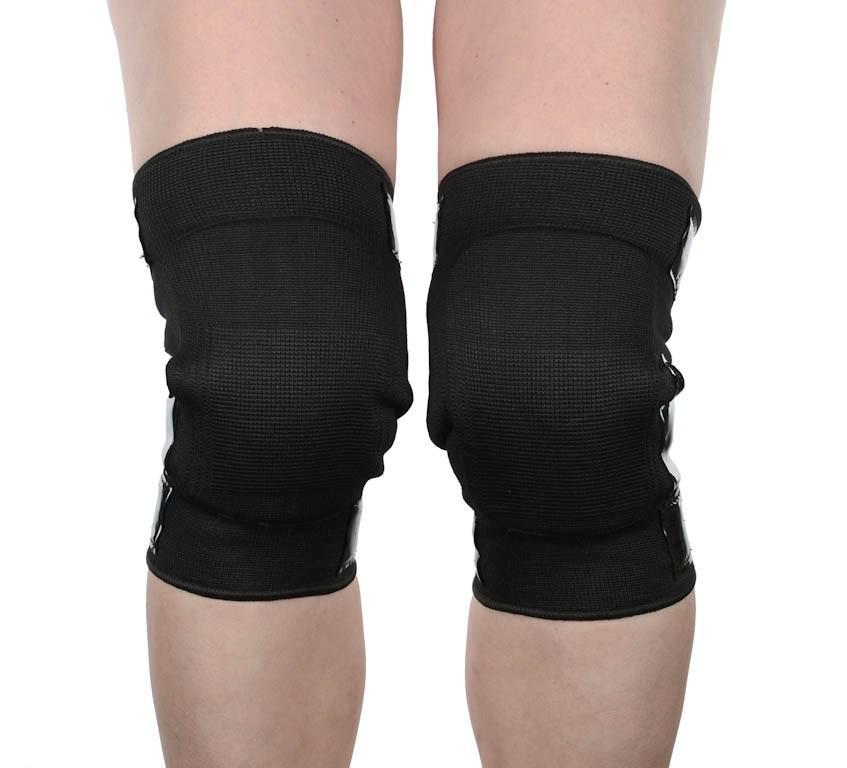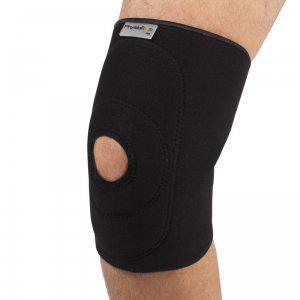The first image is the image on the left, the second image is the image on the right. For the images shown, is this caption "There are two legs in the image on the right." true? Answer yes or no. No. 